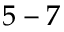<formula> <loc_0><loc_0><loc_500><loc_500>5 - 7</formula> 